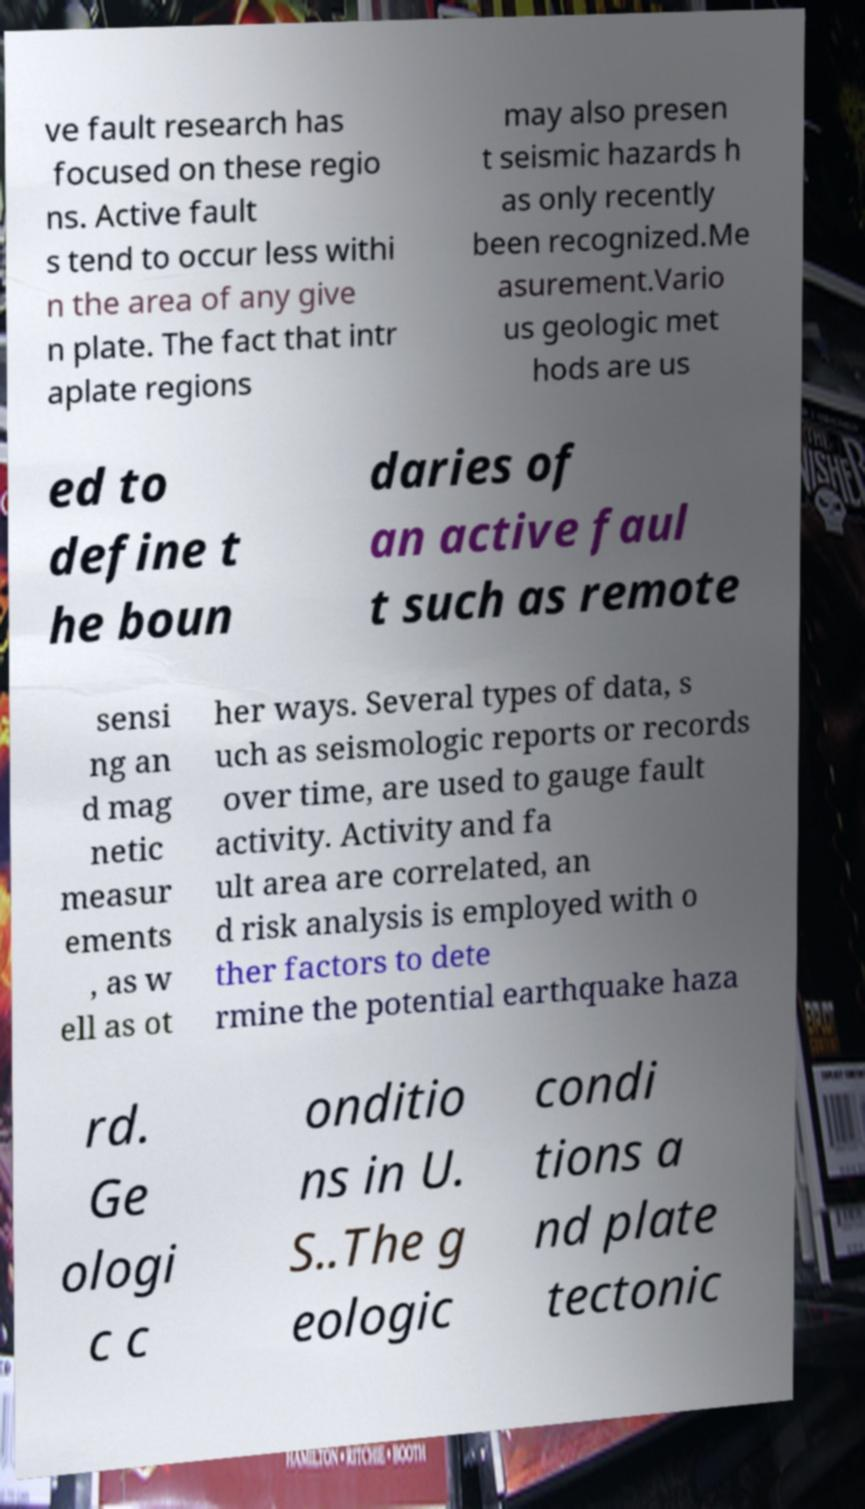Please read and relay the text visible in this image. What does it say? ve fault research has focused on these regio ns. Active fault s tend to occur less withi n the area of any give n plate. The fact that intr aplate regions may also presen t seismic hazards h as only recently been recognized.Me asurement.Vario us geologic met hods are us ed to define t he boun daries of an active faul t such as remote sensi ng an d mag netic measur ements , as w ell as ot her ways. Several types of data, s uch as seismologic reports or records over time, are used to gauge fault activity. Activity and fa ult area are correlated, an d risk analysis is employed with o ther factors to dete rmine the potential earthquake haza rd. Ge ologi c c onditio ns in U. S..The g eologic condi tions a nd plate tectonic 